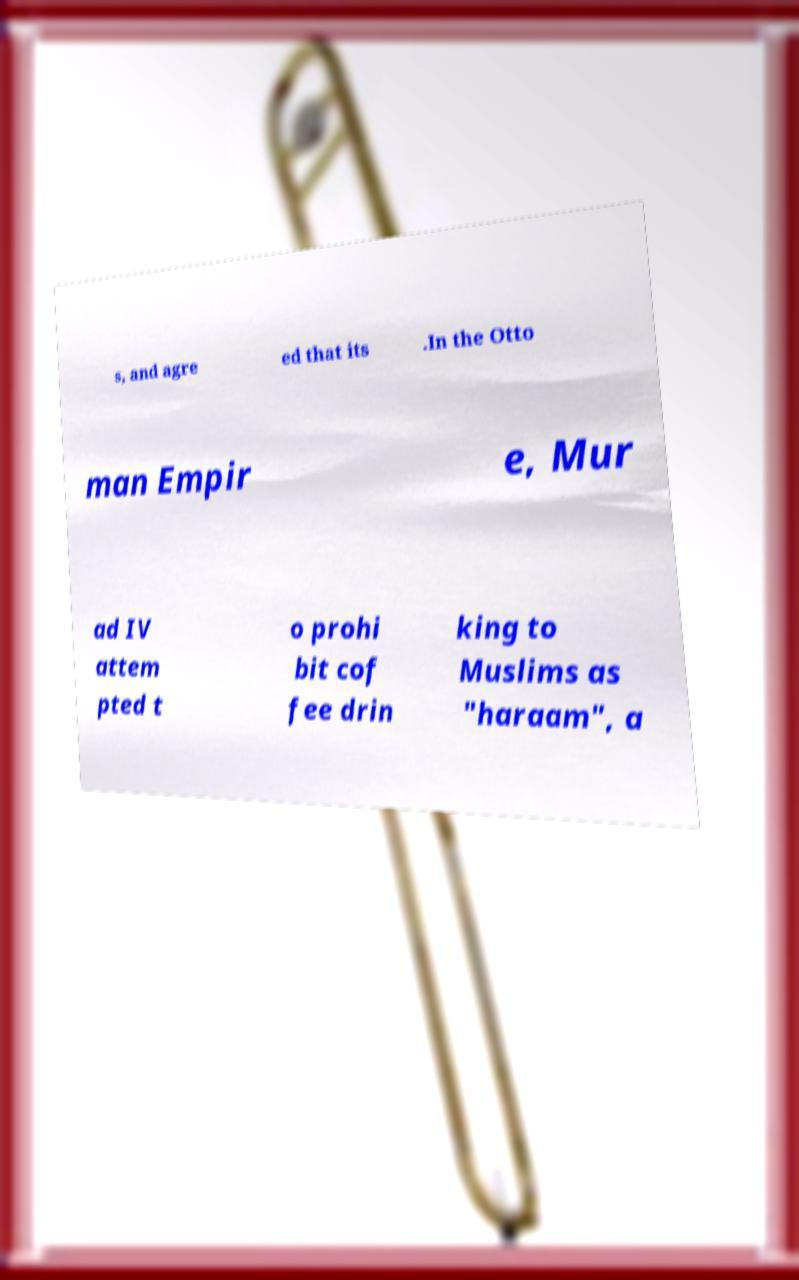Can you accurately transcribe the text from the provided image for me? s, and agre ed that its .In the Otto man Empir e, Mur ad IV attem pted t o prohi bit cof fee drin king to Muslims as "haraam", a 